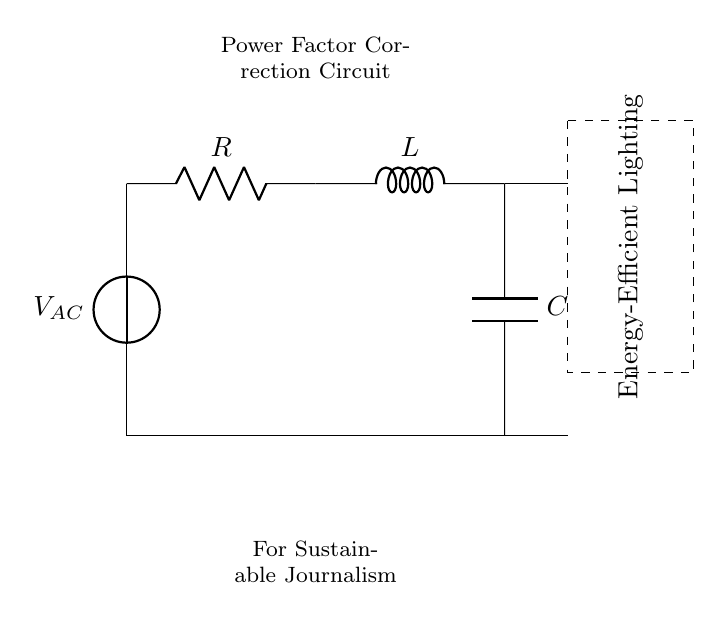What is the type of the energy-efficient lighting system shown in the circuit? The circuit is labeled as an "Energy-Efficient Lighting," indicating its purpose is to enhance energy efficiency in lighting applications.
Answer: Energy-Efficient Lighting What components are present in the circuit? The circuit comprises three main components: a resistor, an inductor, and a capacitor, which are essential for power factor correction.
Answer: Resistor, Inductor, Capacitor What is the role of the resistor in this circuit? The resistor primarily limits the current and dissipates energy as heat, playing a vital role in managing power factor correction in the circuit.
Answer: Current Limiting What type of circuit is depicted here? The combination of the resistor, inductor, and capacitor suggests that this is a "Resistor-Inductor-Capacitor" circuit, typical for power factor correction.
Answer: Resistor-Inductor-Capacitor What is the purpose of power factor correction in this context? Power factor correction is intended to improve energy efficiency and reduce wasted power in the lighting system, making it sustainable.
Answer: Improve Efficiency How does the inductor affect the power factor in this circuit? The inductor introduces inductive reactance, opposing changes in current, and thus contributes to improving the circuit's overall power factor by balancing the resistive load.
Answer: Balancing Power Factor 